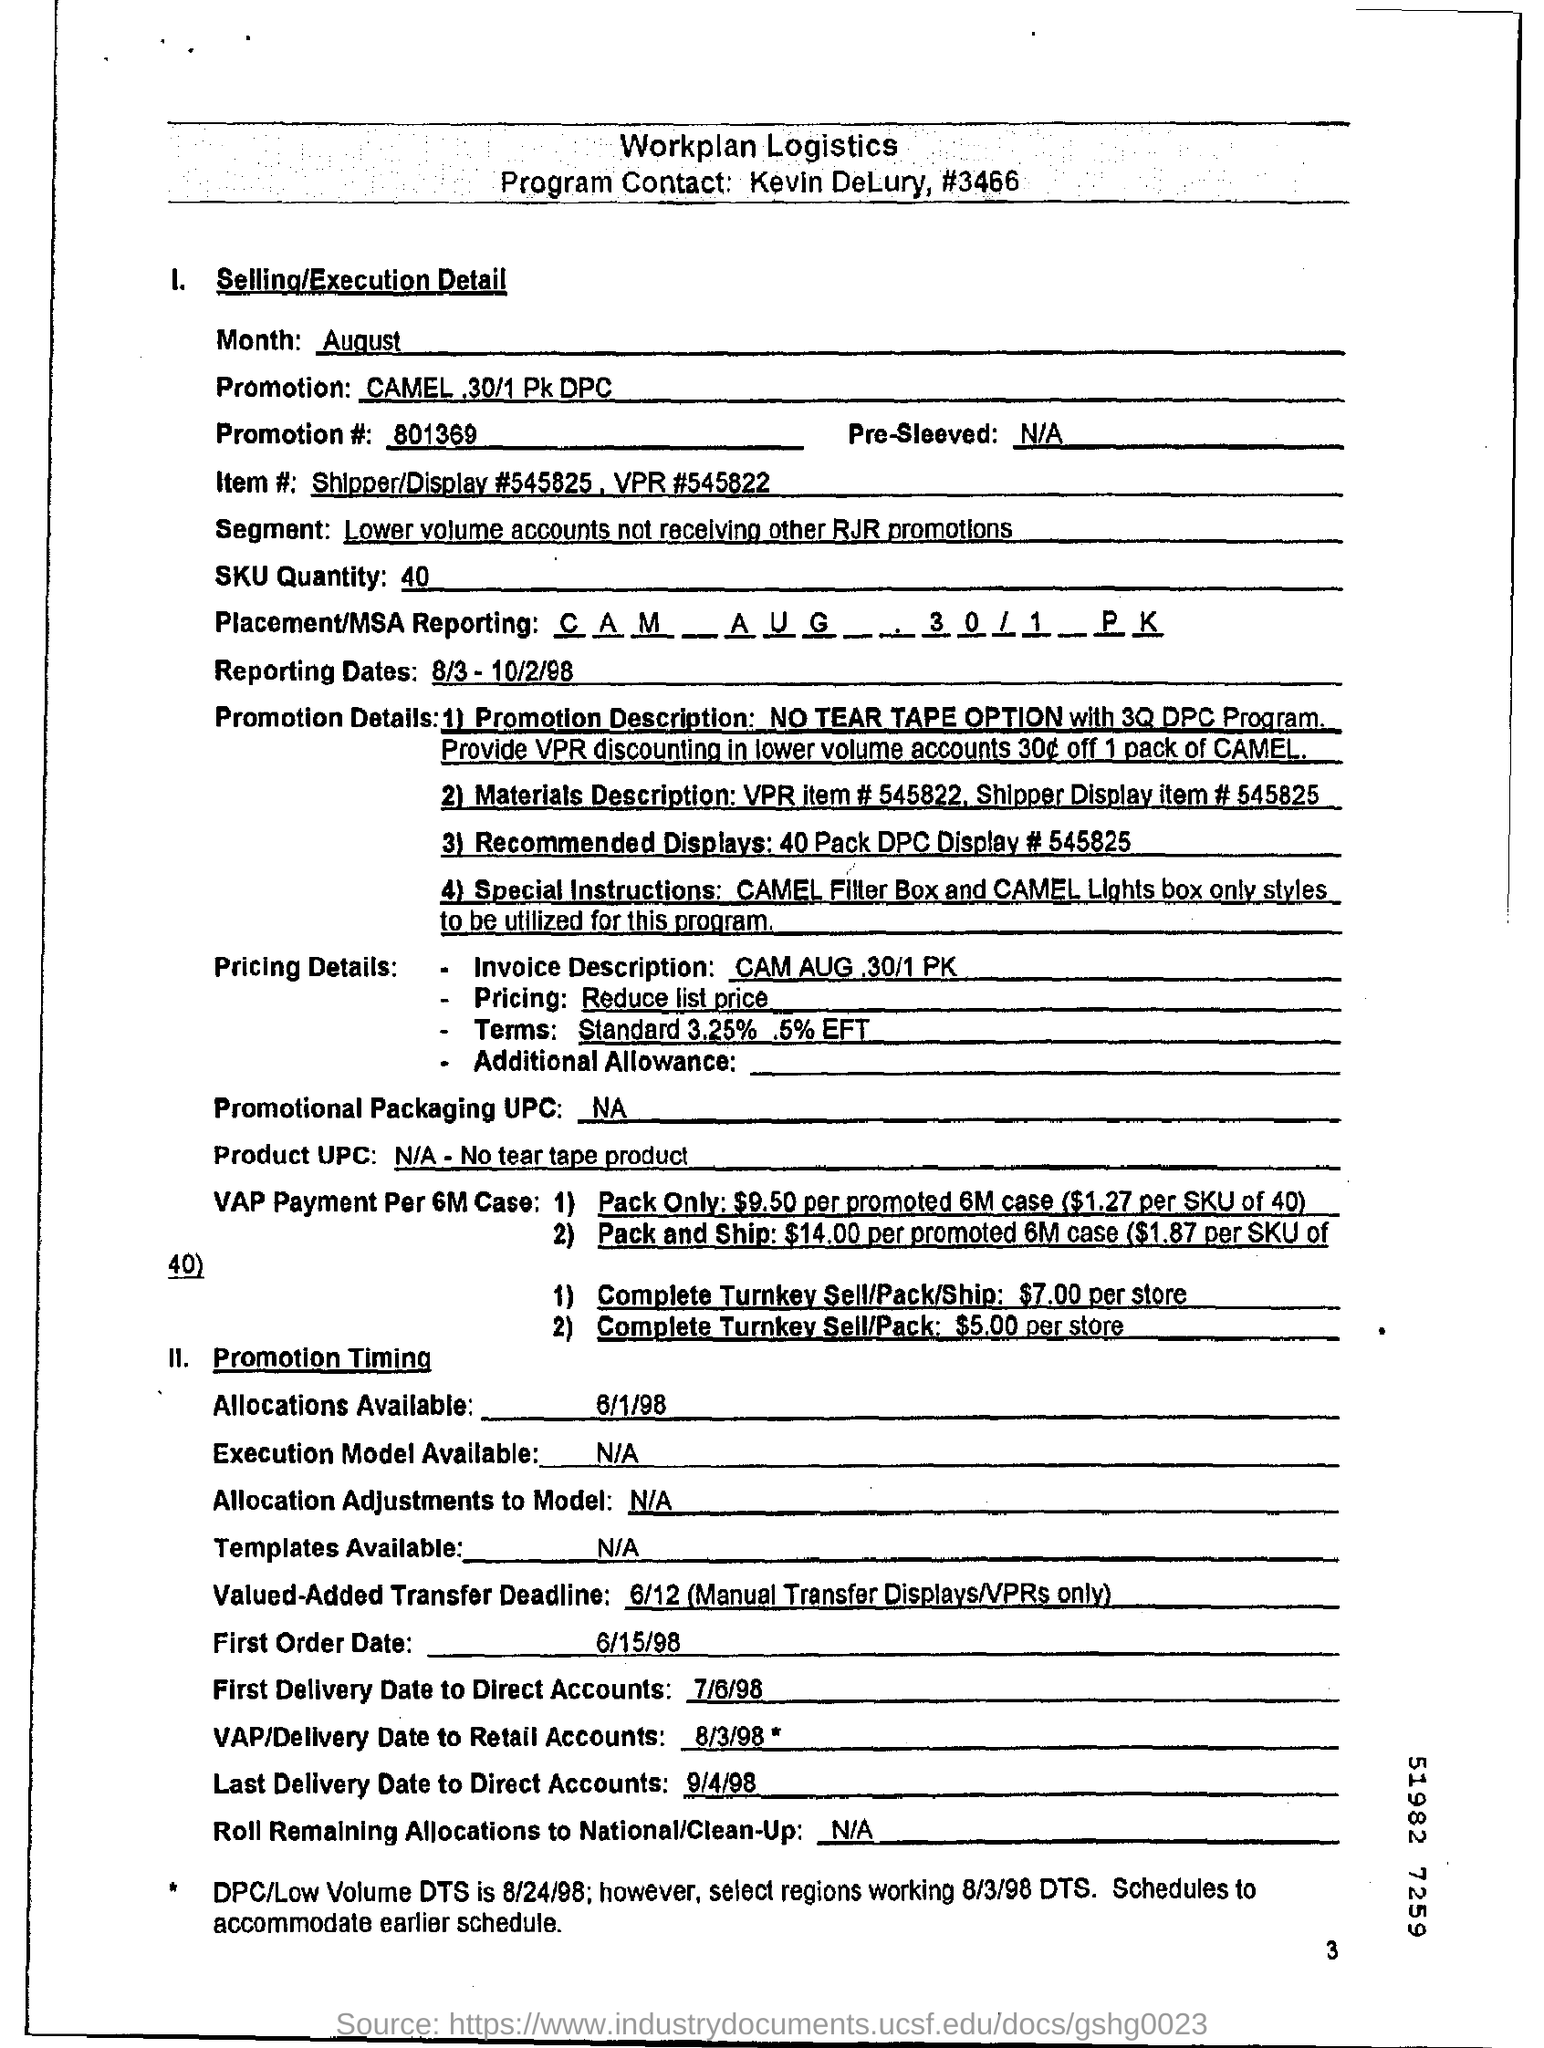Point out several critical features in this image. The last direct account delivery was on September 4, 1998. The SKU quantity is 40. On what date was the first order placed? The order was placed on June 15, 1998. On 6/1/98, allocation is available. There are four promotion details available. 